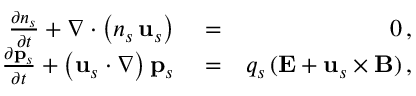<formula> <loc_0><loc_0><loc_500><loc_500>\begin{array} { r l r } { \frac { \partial n _ { s } } { \partial t } + \nabla \cdot \left ( n _ { s } \, { u } _ { s } \right ) } & = } & { 0 \, , } \\ { \frac { \partial { p } _ { s } } { \partial t } + \left ( { u } _ { s } \cdot \nabla \right ) { p } _ { s } } & = } & { q _ { s } \, ( { E } + { u } _ { s } \times { B } ) \, , } \end{array}</formula> 